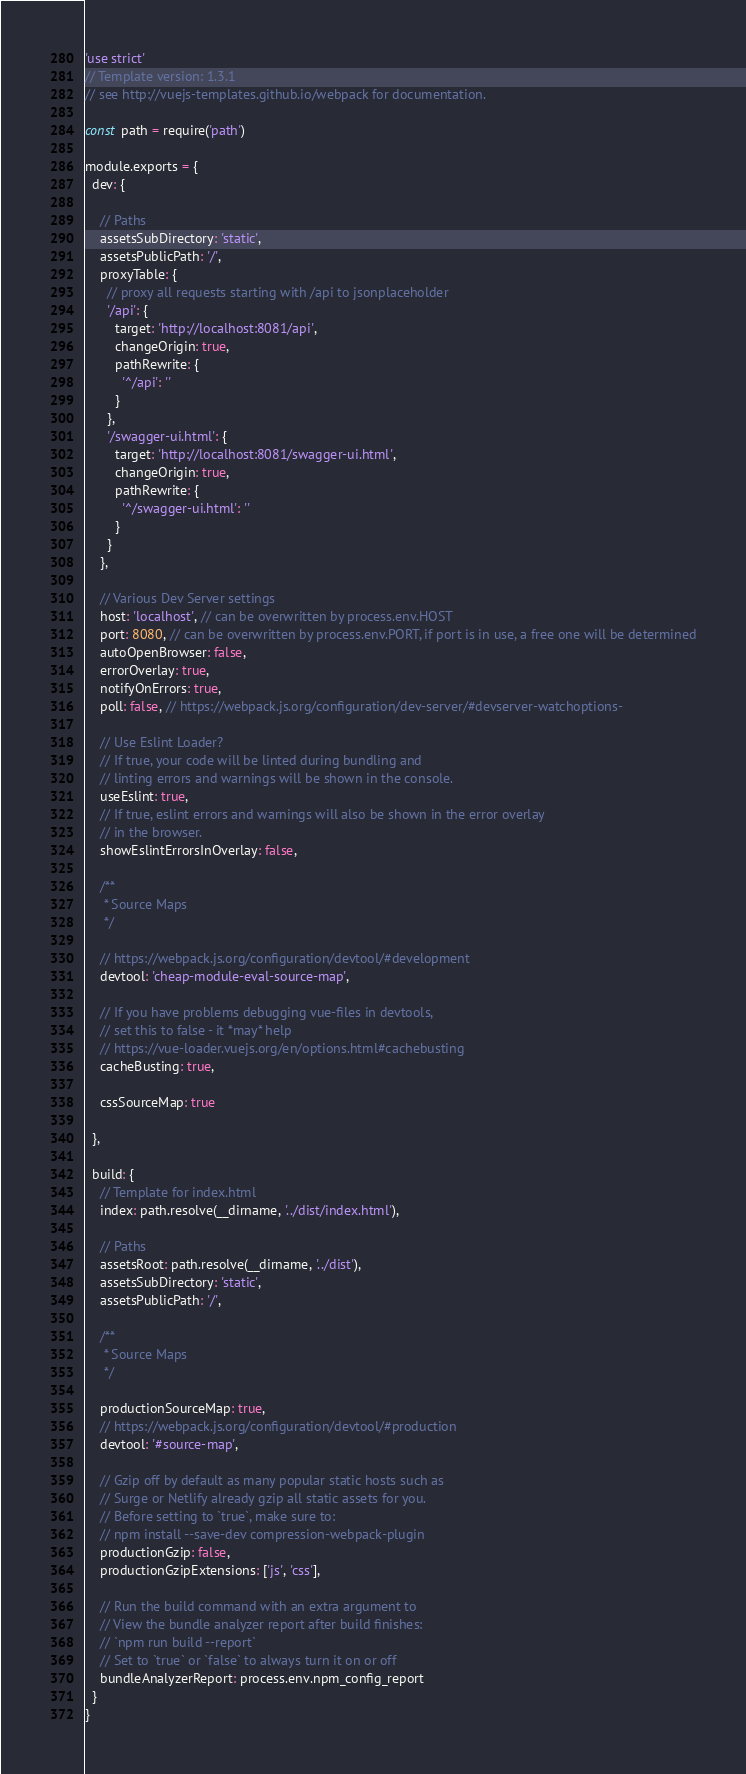<code> <loc_0><loc_0><loc_500><loc_500><_JavaScript_>'use strict'
// Template version: 1.3.1
// see http://vuejs-templates.github.io/webpack for documentation.

const path = require('path')

module.exports = {
  dev: {

    // Paths
    assetsSubDirectory: 'static',
    assetsPublicPath: '/',
    proxyTable: {
      // proxy all requests starting with /api to jsonplaceholder
      '/api': {
        target: 'http://localhost:8081/api',
        changeOrigin: true,
        pathRewrite: {
          '^/api': ''
        }
      },
      '/swagger-ui.html': {
        target: 'http://localhost:8081/swagger-ui.html',
        changeOrigin: true,
        pathRewrite: {
          '^/swagger-ui.html': ''
        }
      }
    },

    // Various Dev Server settings
    host: 'localhost', // can be overwritten by process.env.HOST
    port: 8080, // can be overwritten by process.env.PORT, if port is in use, a free one will be determined
    autoOpenBrowser: false,
    errorOverlay: true,
    notifyOnErrors: true,
    poll: false, // https://webpack.js.org/configuration/dev-server/#devserver-watchoptions-

    // Use Eslint Loader?
    // If true, your code will be linted during bundling and
    // linting errors and warnings will be shown in the console.
    useEslint: true,
    // If true, eslint errors and warnings will also be shown in the error overlay
    // in the browser.
    showEslintErrorsInOverlay: false,

    /**
     * Source Maps
     */

    // https://webpack.js.org/configuration/devtool/#development
    devtool: 'cheap-module-eval-source-map',

    // If you have problems debugging vue-files in devtools,
    // set this to false - it *may* help
    // https://vue-loader.vuejs.org/en/options.html#cachebusting
    cacheBusting: true,

    cssSourceMap: true

  },

  build: {
    // Template for index.html
    index: path.resolve(__dirname, '../dist/index.html'),

    // Paths
    assetsRoot: path.resolve(__dirname, '../dist'),
    assetsSubDirectory: 'static',
    assetsPublicPath: '/',

    /**
     * Source Maps
     */

    productionSourceMap: true,
    // https://webpack.js.org/configuration/devtool/#production
    devtool: '#source-map',

    // Gzip off by default as many popular static hosts such as
    // Surge or Netlify already gzip all static assets for you.
    // Before setting to `true`, make sure to:
    // npm install --save-dev compression-webpack-plugin
    productionGzip: false,
    productionGzipExtensions: ['js', 'css'],

    // Run the build command with an extra argument to
    // View the bundle analyzer report after build finishes:
    // `npm run build --report`
    // Set to `true` or `false` to always turn it on or off
    bundleAnalyzerReport: process.env.npm_config_report
  }
}
</code> 